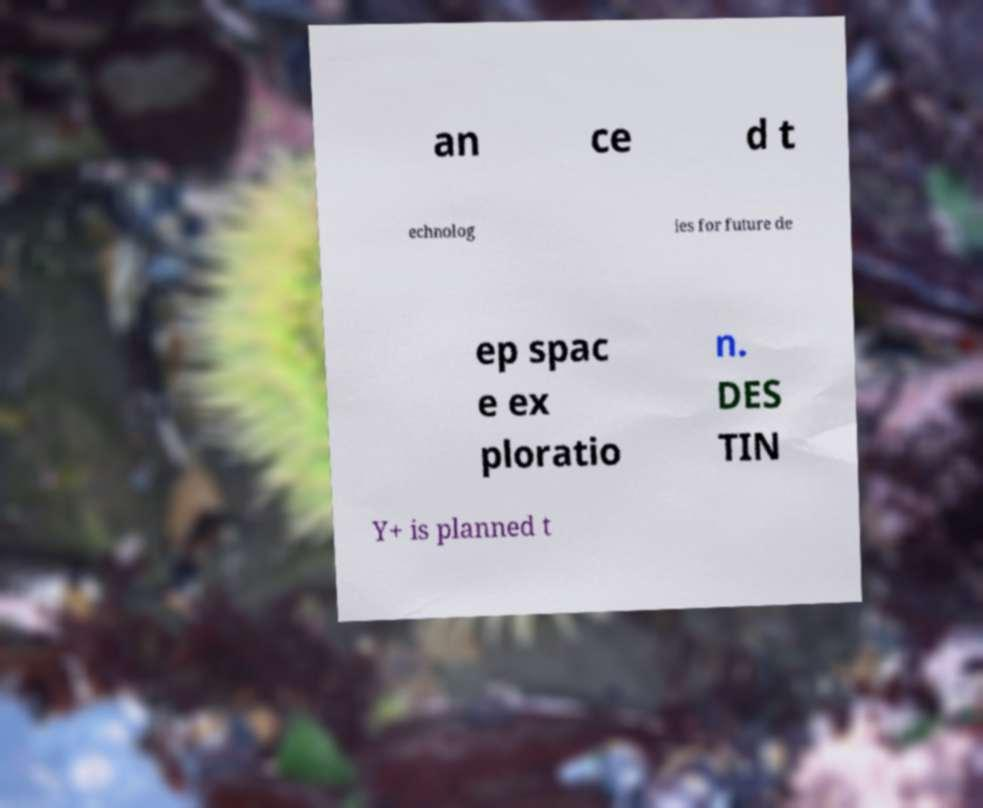Please identify and transcribe the text found in this image. an ce d t echnolog ies for future de ep spac e ex ploratio n. DES TIN Y+ is planned t 